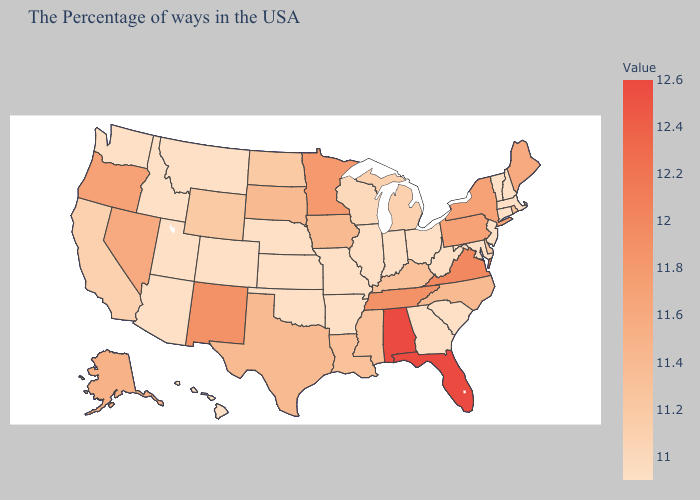Does Mississippi have a higher value than Florida?
Concise answer only. No. Which states hav the highest value in the West?
Quick response, please. New Mexico. Which states have the lowest value in the South?
Give a very brief answer. Maryland, South Carolina, West Virginia, Georgia, Arkansas, Oklahoma. Among the states that border Idaho , which have the highest value?
Quick response, please. Oregon. Among the states that border Massachusetts , does Connecticut have the highest value?
Quick response, please. No. Among the states that border Wyoming , does Utah have the lowest value?
Answer briefly. Yes. Which states have the lowest value in the West?
Be succinct. Colorado, Utah, Montana, Arizona, Idaho, Washington, Hawaii. Which states have the lowest value in the MidWest?
Concise answer only. Ohio, Indiana, Illinois, Missouri, Kansas, Nebraska. Among the states that border Wyoming , does South Dakota have the highest value?
Keep it brief. Yes. 